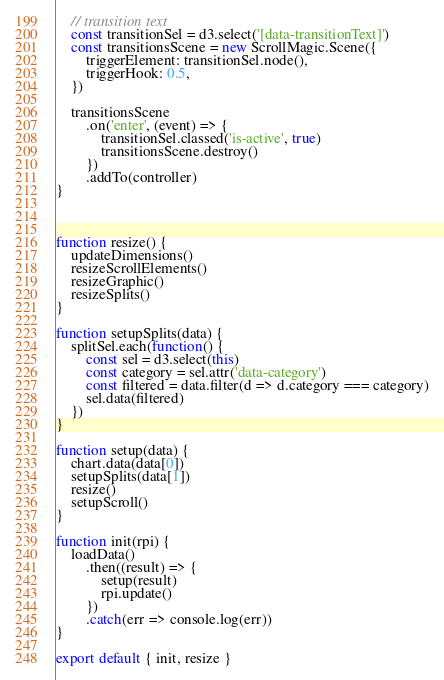<code> <loc_0><loc_0><loc_500><loc_500><_JavaScript_>    // transition text
    const transitionSel = d3.select('[data-transitionText]')
    const transitionsScene = new ScrollMagic.Scene({
        triggerElement: transitionSel.node(),
        triggerHook: 0.5,
    })

    transitionsScene
        .on('enter', (event) => {
            transitionSel.classed('is-active', true)
            transitionsScene.destroy()
        })
        .addTo(controller)
}



function resize() {
    updateDimensions()
    resizeScrollElements()
    resizeGraphic()
    resizeSplits()
}

function setupSplits(data) {
    splitSel.each(function() {
        const sel = d3.select(this)
        const category = sel.attr('data-category')
        const filtered = data.filter(d => d.category === category)
        sel.data(filtered)
    })
}

function setup(data) {
    chart.data(data[0])
    setupSplits(data[1])
    resize()
    setupScroll()
}

function init(rpi) {
    loadData()
        .then((result) => {
            setup(result)
            rpi.update()
        })
        .catch(err => console.log(err))
}

export default { init, resize }
</code> 